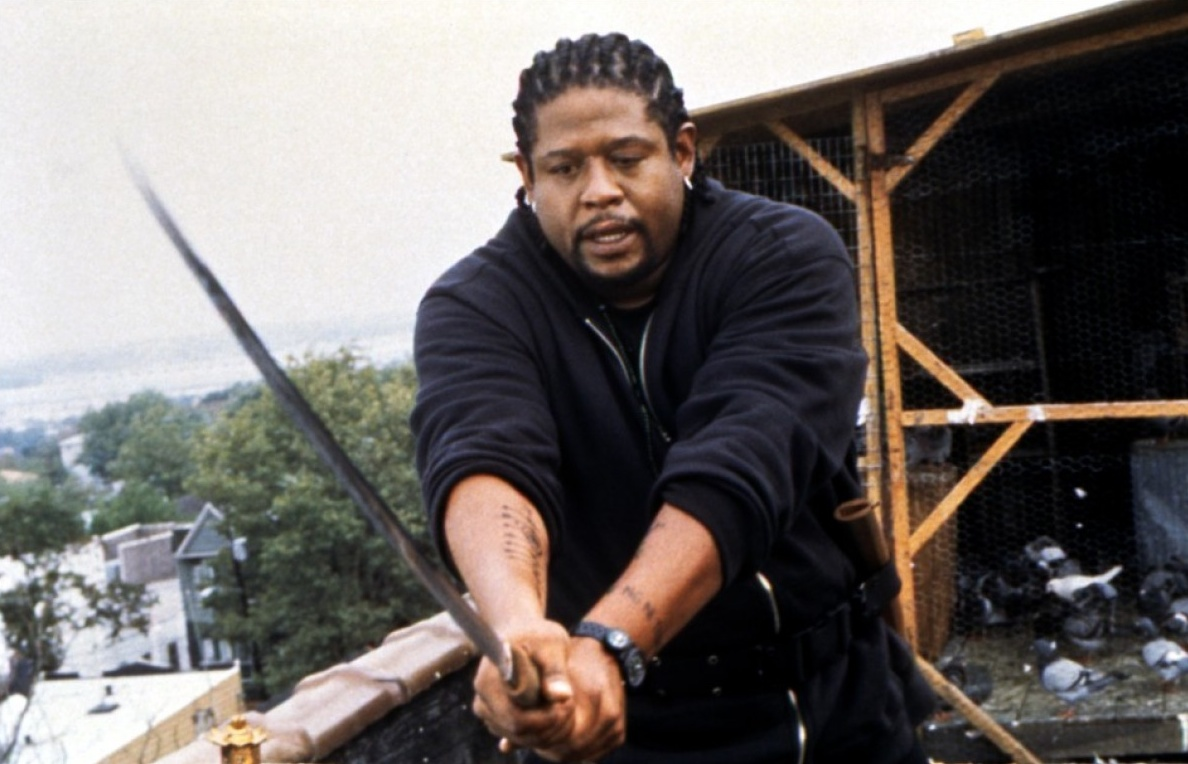Explain the visual content of the image in great detail. In this image, we see an individual who appears to be in character from a film or television show. The person is standing on a rooftop, with a sprawling cityscape stretching out behind them. Clad in a black jacket and pants, they hold a sword firmly in both hands, ready for combat. Their hair is styled in dreadlocks, adding to the intensity of their character. Several tattoos are visible on their forearms. Their face is etched with determination, indicating that they are in the midst of a pivotal moment. The image captures a scene of heightened tension, portraying them as a formidable and focused warrior. Additionally, the background includes a wooden structure that seems to house pigeons, further adding to the urban setting. 